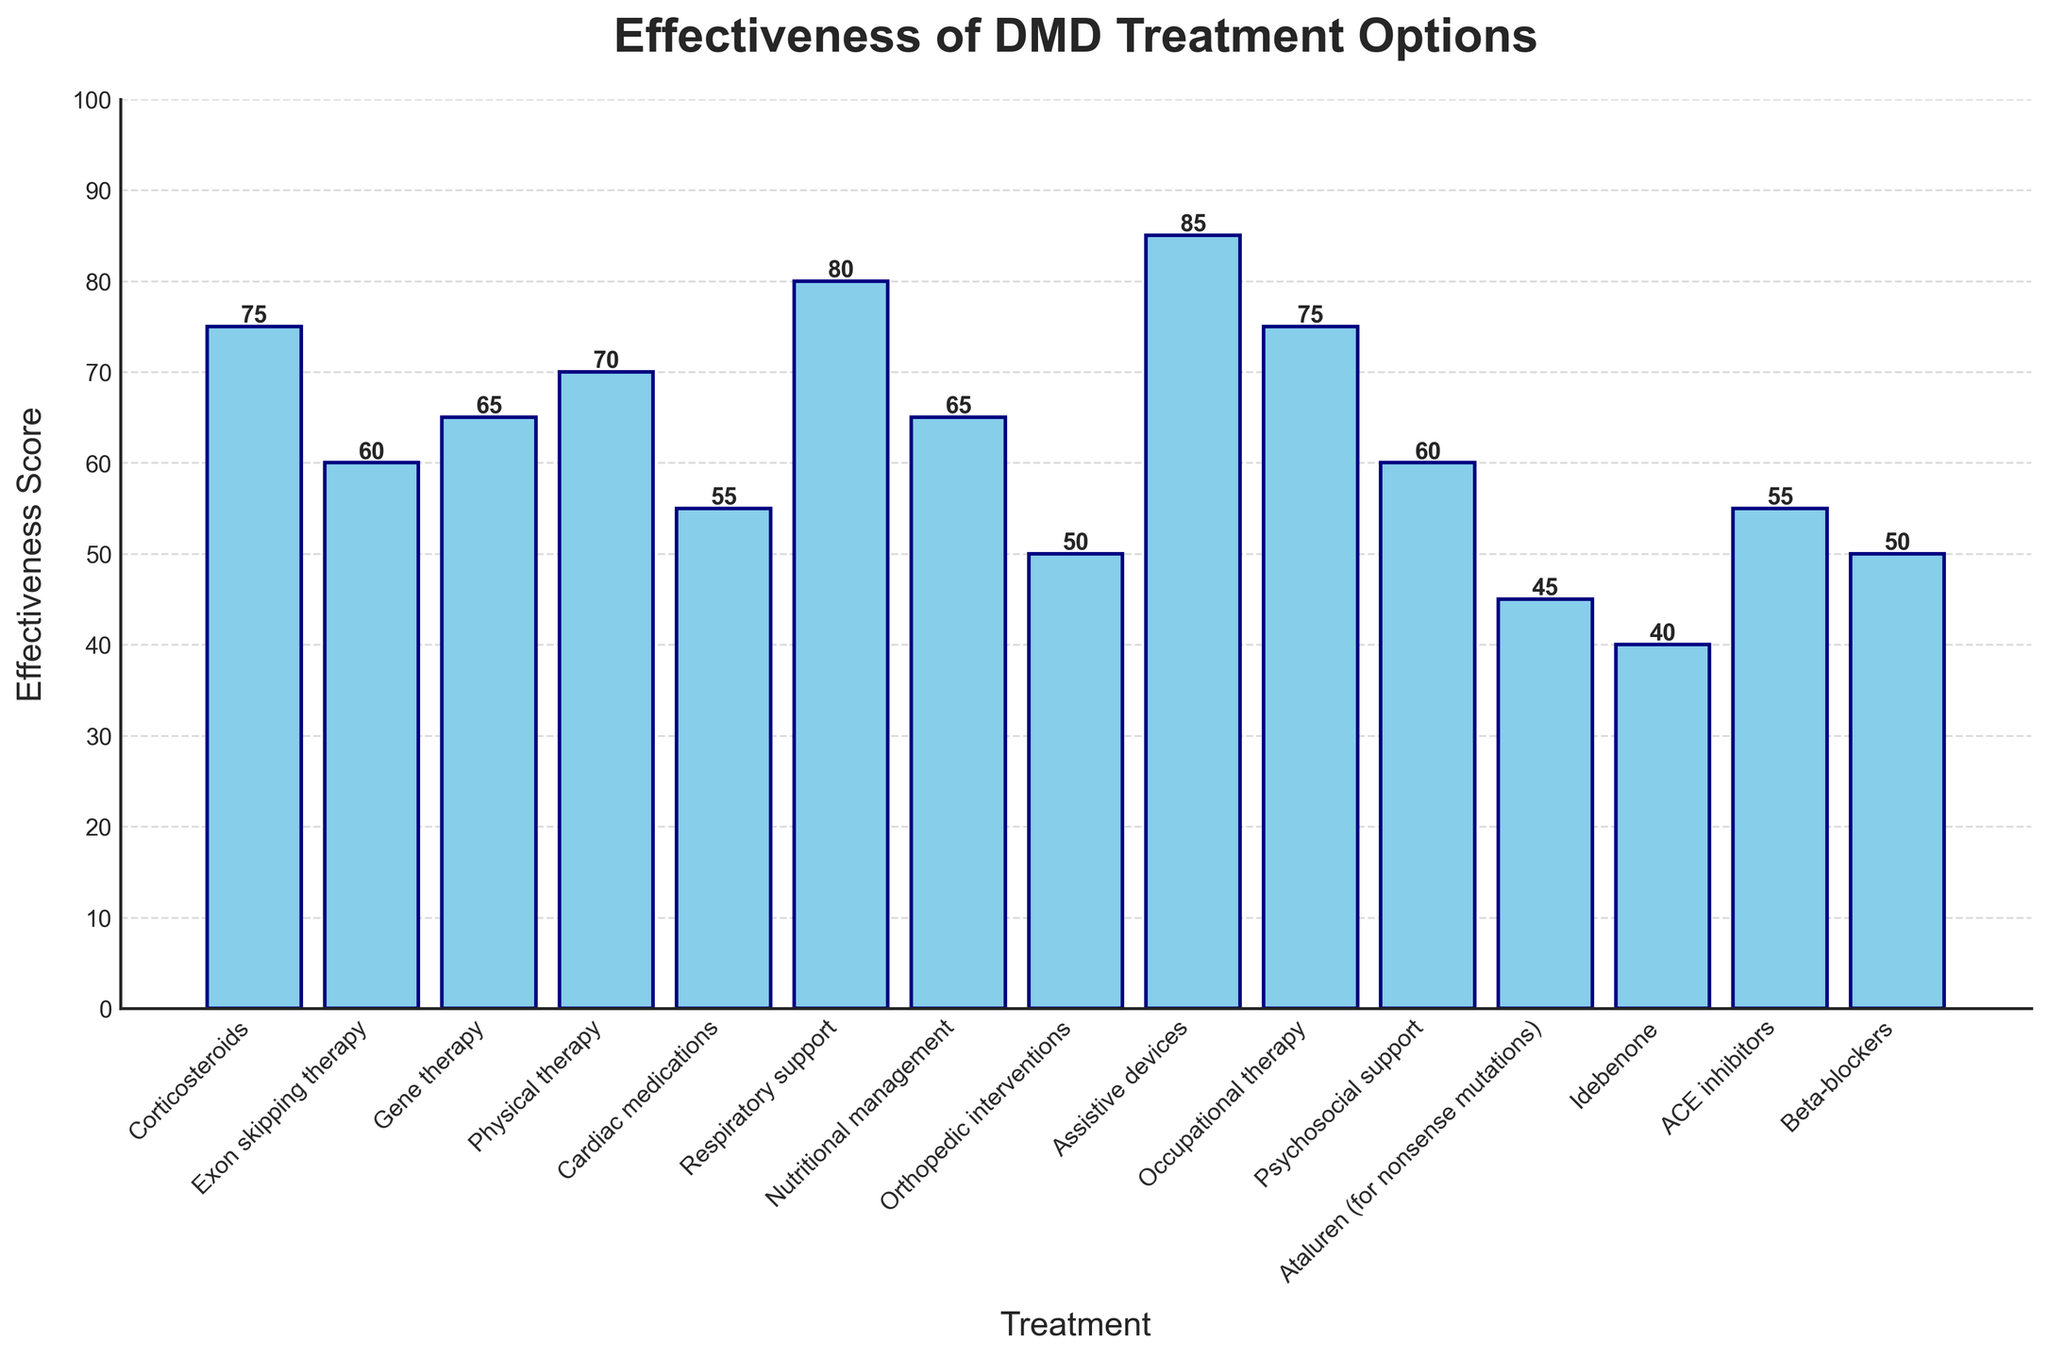Which treatment option has the highest effectiveness score? To find the highest effectiveness score, look for the tallest bar in the chart. The "Assistive devices" bar is the tallest with a score of 85.
Answer: Assistive devices What is the effectiveness score for Gene therapy? Locate the bar labeled "Gene therapy" and read its height. The height corresponds to the effectiveness score, which is 65.
Answer: 65 Between Physical therapy and Occupational therapy, which one has a higher effectiveness score? Compare the heights of the bars labeled "Physical therapy" and "Occupational therapy". Both bars are of equal height, indicating they have the same effectiveness score, which is 75.
Answer: They are equal Which treatments have an effectiveness score less than 50? Identify the bars that do not reach the height corresponding to the score of 50. The treatments are "Ataluren (for nonsense mutations)" with a score of 45 and "Idebenone" with a score of 40.
Answer: Ataluren (for nonsense mutations), Idebenone By how much is Respiratory support more effective than Cardiac medications? Find the heights of the bars for "Respiratory support" and "Cardiac medications". Subtract the effectiveness score of Cardiac medications (55) from that of Respiratory support (80).
Answer: 25 Which treatments have exactly the same effectiveness score? Look for bars of equal height and note their labels. "Gene therapy" and "Nutritional management" both have a score of 65. Additionally, "ACE inhibitors" and "Cardiac medications" both have a score of 55.
Answer: Gene therapy and Nutritional management; ACE inhibitors and Cardiac medications What is the combined effectiveness score of Exon skipping therapy and Psychosocial support? Add the effectiveness scores of Exon skipping therapy (60) and Psychosocial support (60). The combined score is 60 + 60 = 120.
Answer: 120 Which treatment option has the second highest effectiveness score? Identify the highest effectiveness score (85 for Assistive devices) and then locate the next tallest bar. "Respiratory support" has the second-highest score of 80.
Answer: Respiratory support What is the average effectiveness score of the treatments listed? Sum all the effectiveness scores and divide by the number of treatments. The sum is 75 + 60 + 65 + 70 + 55 + 80 + 65 + 50 + 85 + 75 + 60 + 45 + 40 + 55 + 50 = 930. There are 15 treatments, so the average score is 930 / 15 = 62.
Answer: 62 How many treatments have an effectiveness score greater than or equal to 70? Count the bars with heights that correspond to scores 70 and above. These are "Corticosteroids" (75), "Physical therapy" (70), "Respiratory support" (80), "Assistive devices" (85), and "Occupational therapy" (75). There are 5 treatments in total.
Answer: 5 